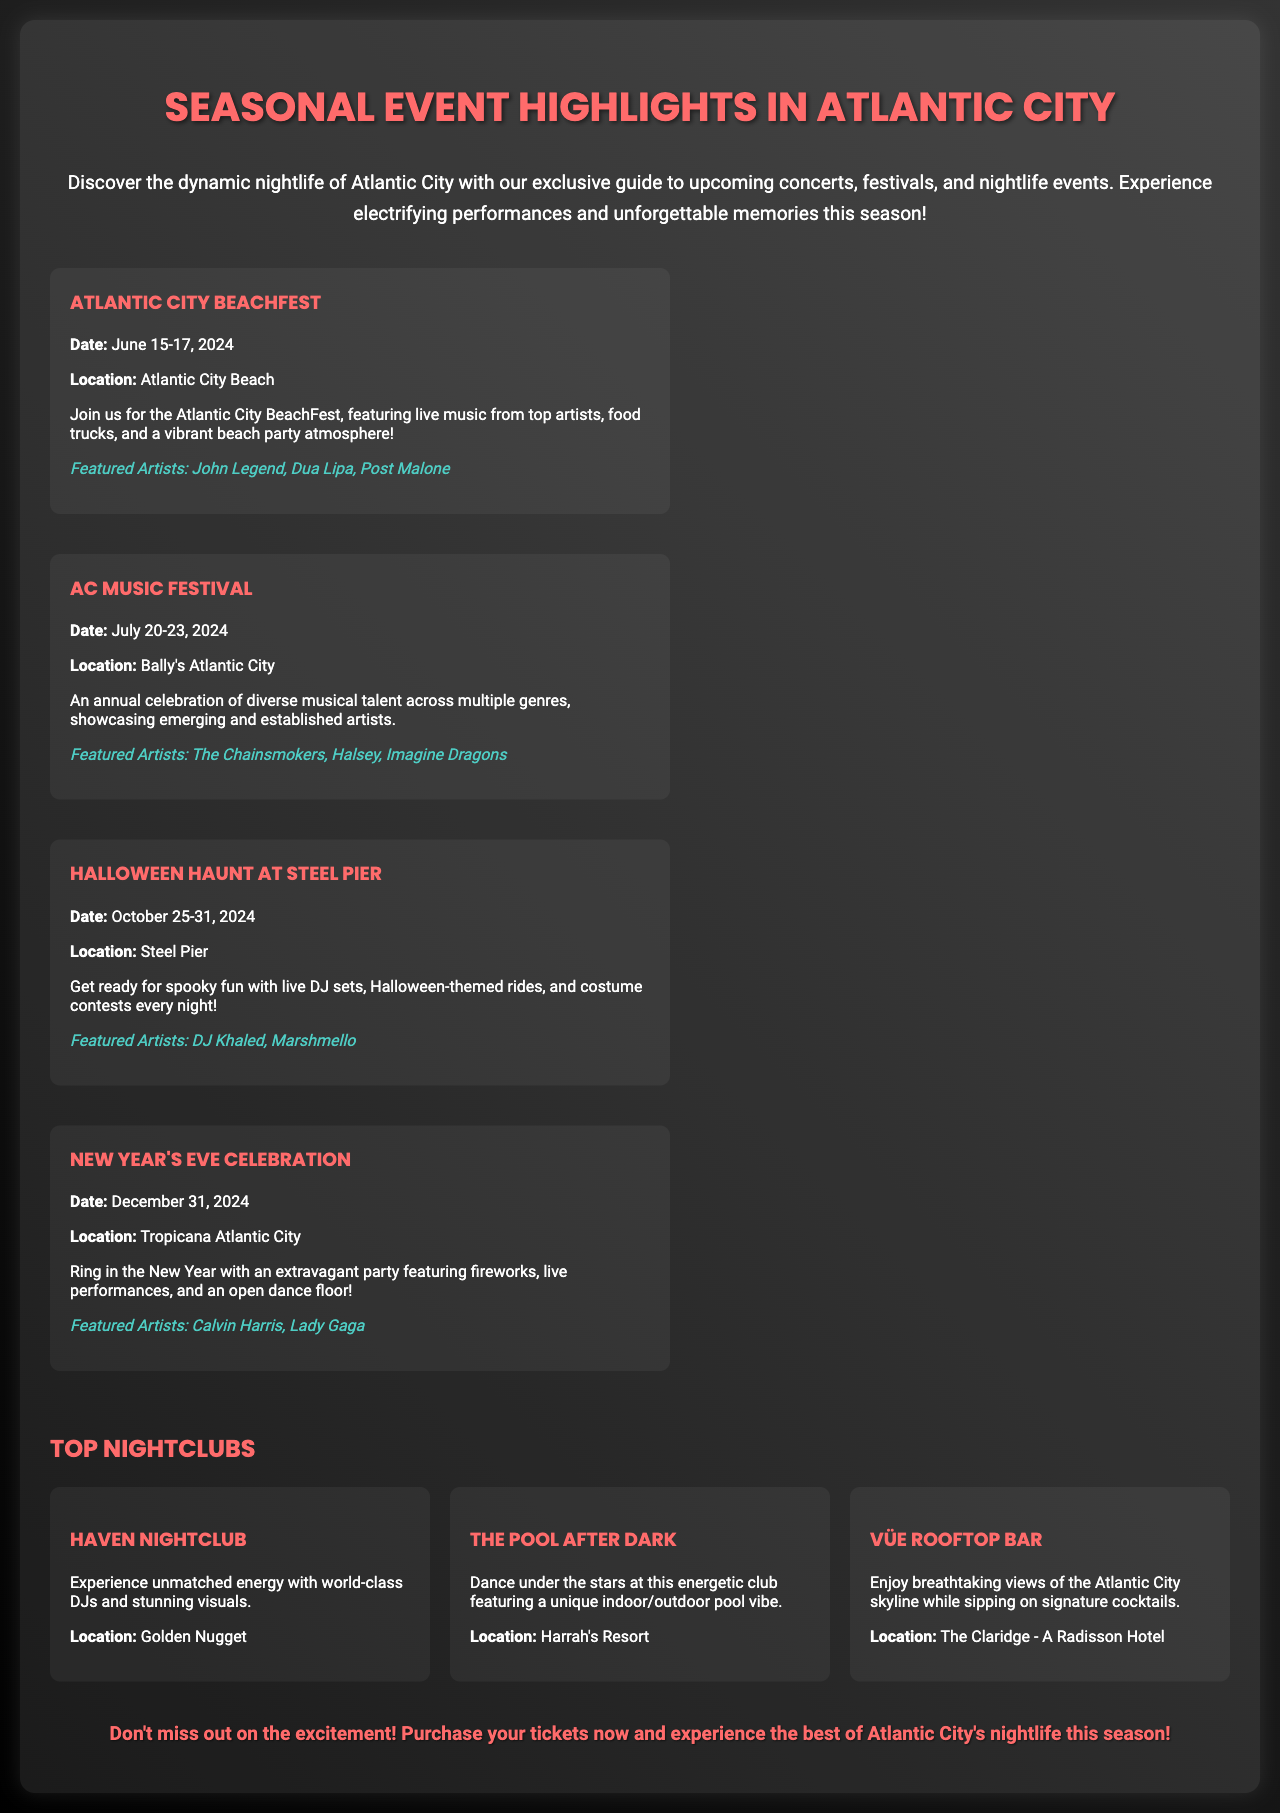what is the date of the Atlantic City BeachFest? The document specifies the date for the Atlantic City BeachFest, which is June 15-17, 2024.
Answer: June 15-17, 2024 who are the featured artists at the AC Music Festival? The document lists the featured artists for the AC Music Festival, which are The Chainsmokers, Halsey, and Imagine Dragons.
Answer: The Chainsmokers, Halsey, Imagine Dragons where is the New Year's Eve Celebration being held? The location for the New Year's Eve Celebration is mentioned in the document, which is Tropicana Atlantic City.
Answer: Tropicana Atlantic City what type of atmosphere will the Atlantic City BeachFest provide? The document describes the atmosphere of the Atlantic City BeachFest as a vibrant beach party atmosphere.
Answer: Vibrant beach party atmosphere how many nightclubs are highlighted in the brochure? The document lists three nightclubs, so the total number can be easily determined.
Answer: Three which artist will perform at the Halloween Haunt at Steel Pier? The document reveals that DJ Khaled and Marshmello are the featured artists at the Halloween Haunt.
Answer: DJ Khaled, Marshmello what unique feature does The Pool After Dark have? The document describes The Pool After Dark as having a unique indoor/outdoor pool vibe.
Answer: Indoor/outdoor pool vibe what is the primary focus of the brochure? The main focus of the brochure is detailed in the introduction, which is to highlight upcoming concerts, festivals, and nightlife events.
Answer: Upcoming concerts, festivals, and nightlife events when will the AC Music Festival take place? The specified date for the AC Music Festival is clearly stated as July 20-23, 2024.
Answer: July 20-23, 2024 